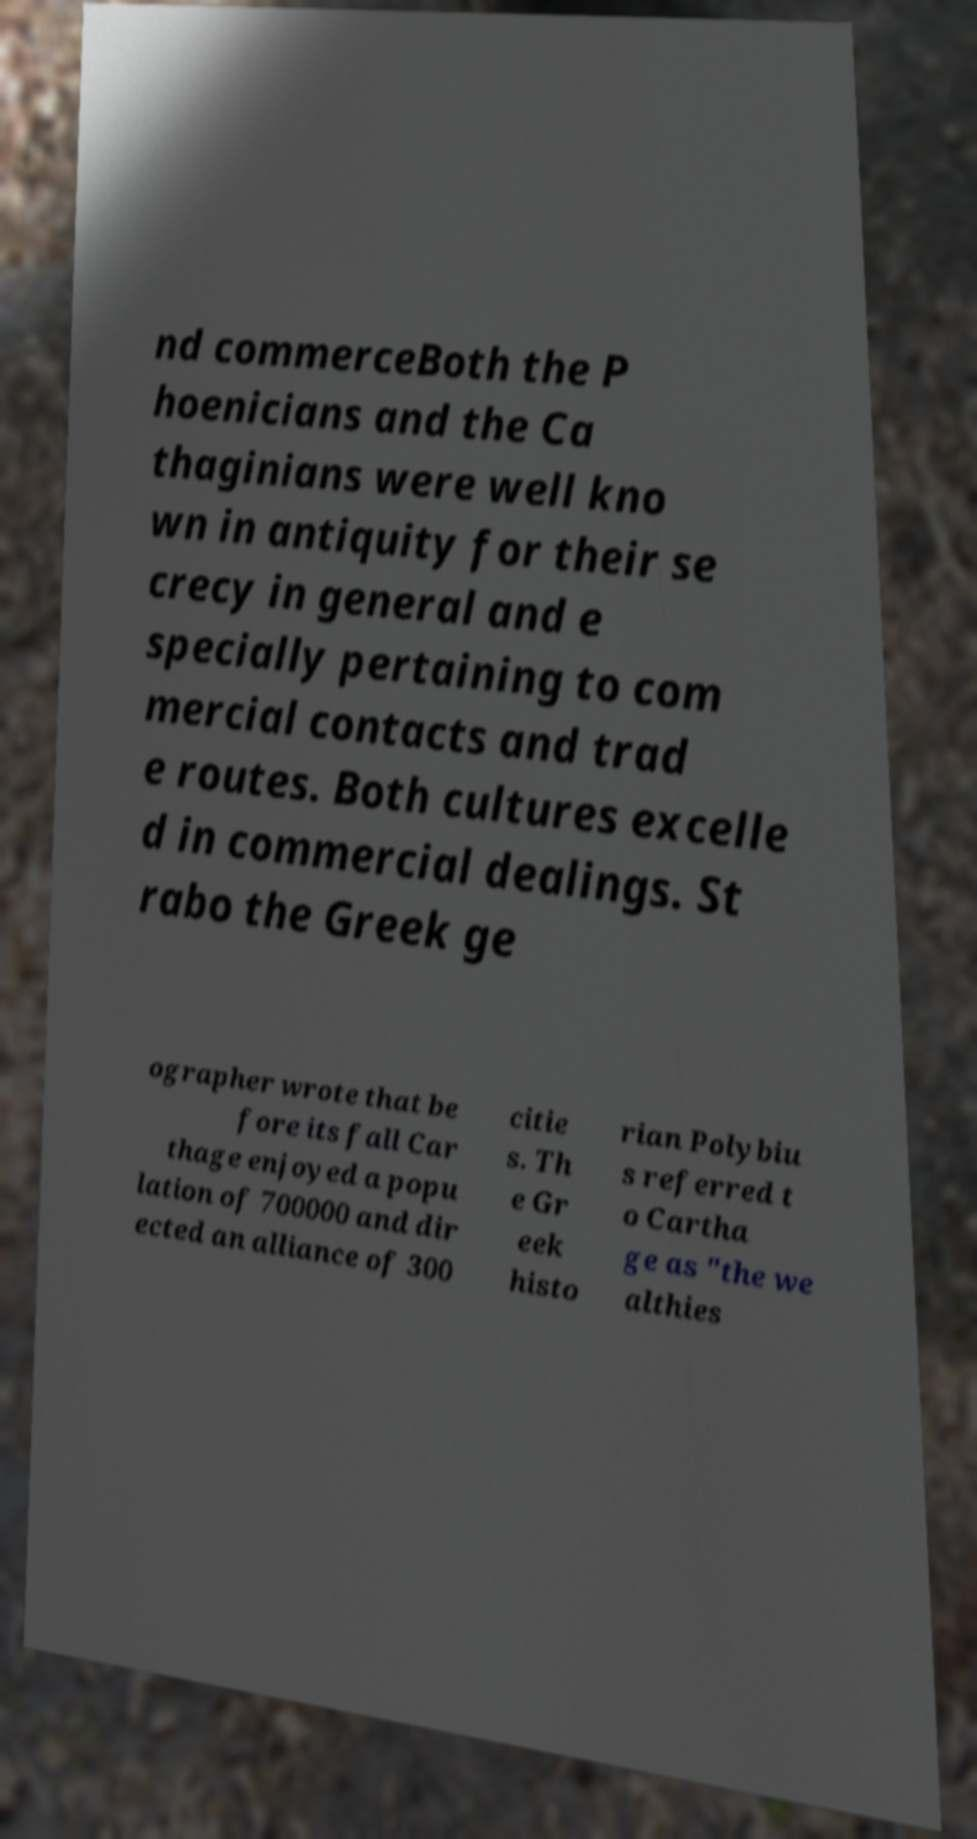There's text embedded in this image that I need extracted. Can you transcribe it verbatim? nd commerceBoth the P hoenicians and the Ca thaginians were well kno wn in antiquity for their se crecy in general and e specially pertaining to com mercial contacts and trad e routes. Both cultures excelle d in commercial dealings. St rabo the Greek ge ographer wrote that be fore its fall Car thage enjoyed a popu lation of 700000 and dir ected an alliance of 300 citie s. Th e Gr eek histo rian Polybiu s referred t o Cartha ge as "the we althies 